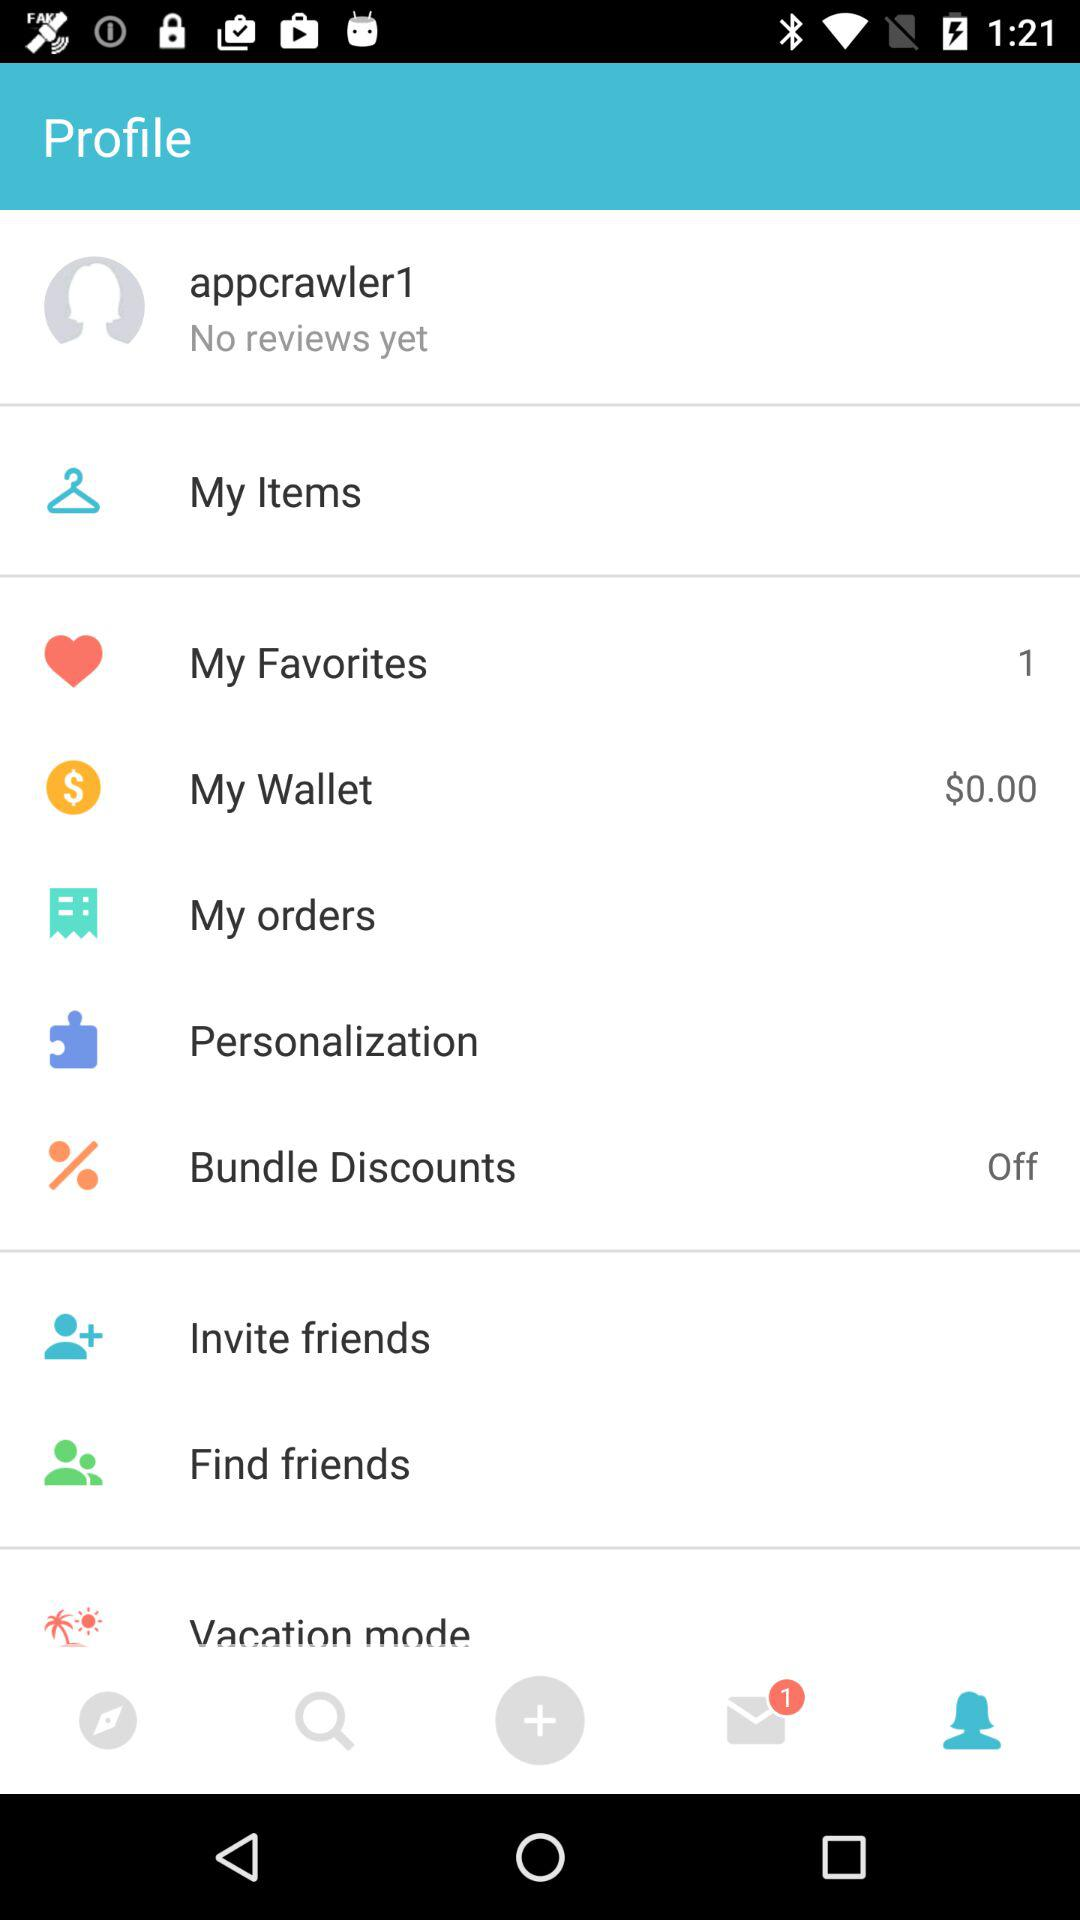Are there any unread messages? There is 1 unread message. 